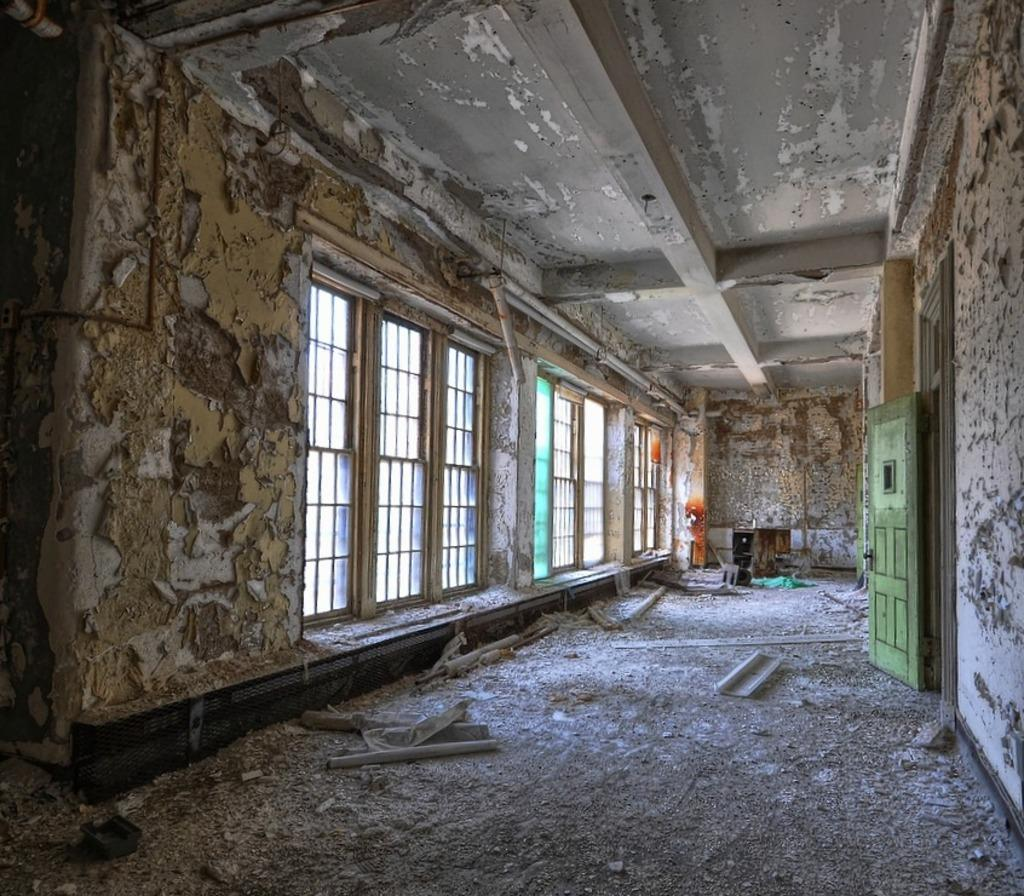What type of structure is shown in the image? The image depicts an old building. What can be seen in the background of the image? There are windows and a wall in the background of the image. Where is the door located in the image? The door is on the right side of the image. What is present on the floor in the image? There is debris on the floor of the image. What is visible at the top of the image? The image shows a ceiling at the top. What type of butter is being used to clean the windows in the image? There is no butter present in the image, and the windows are not being cleaned. 